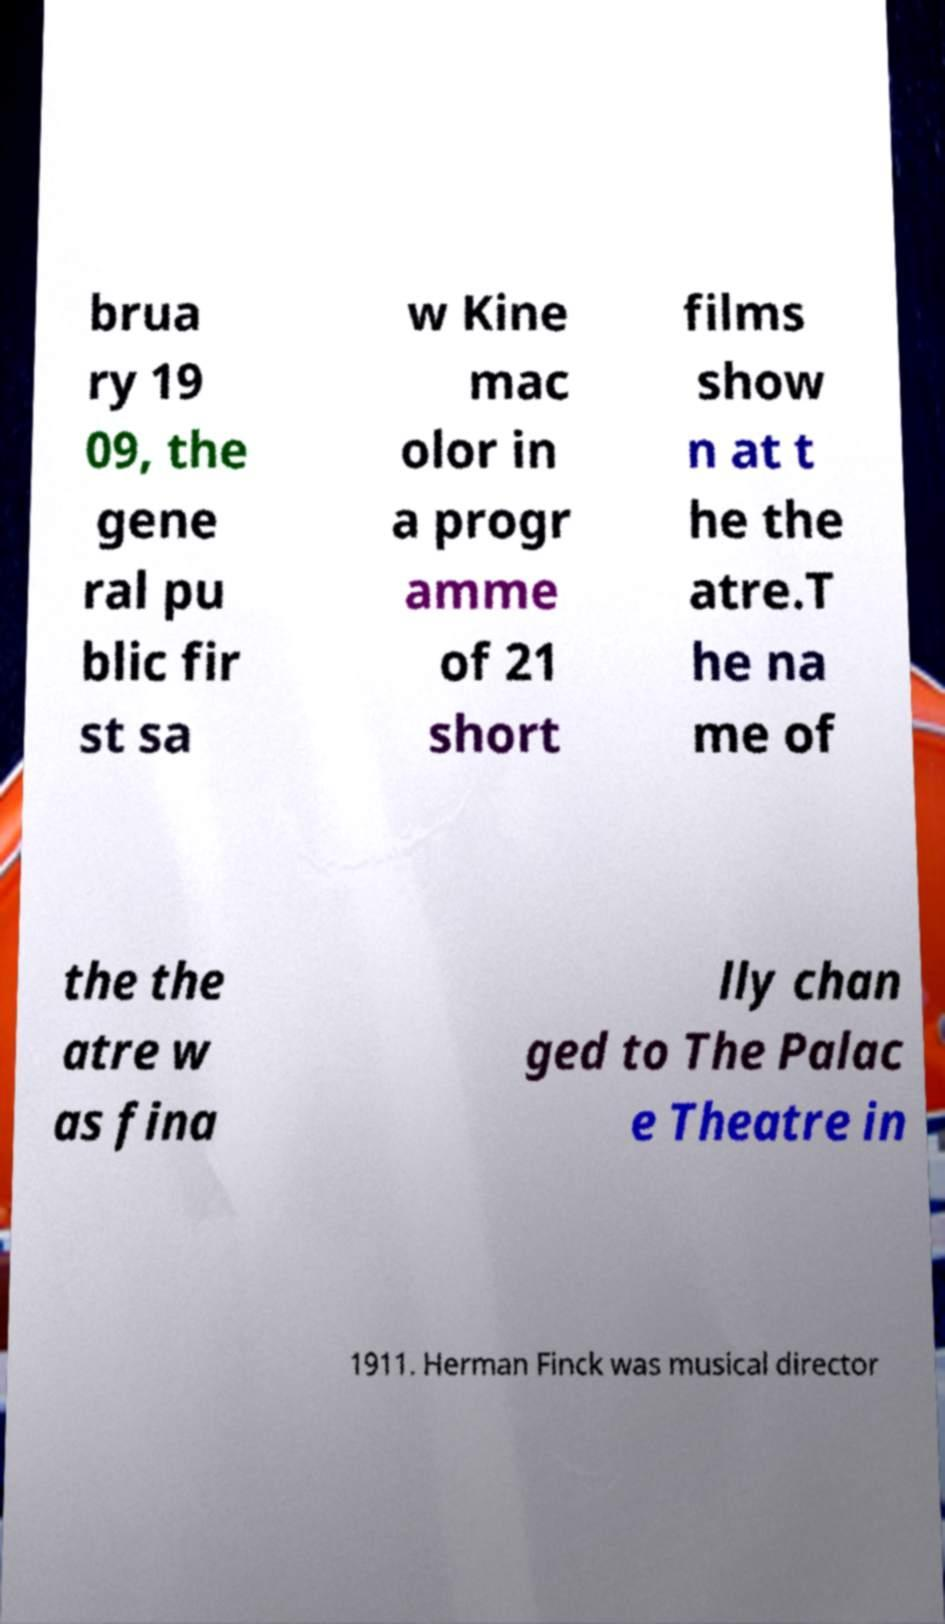For documentation purposes, I need the text within this image transcribed. Could you provide that? brua ry 19 09, the gene ral pu blic fir st sa w Kine mac olor in a progr amme of 21 short films show n at t he the atre.T he na me of the the atre w as fina lly chan ged to The Palac e Theatre in 1911. Herman Finck was musical director 